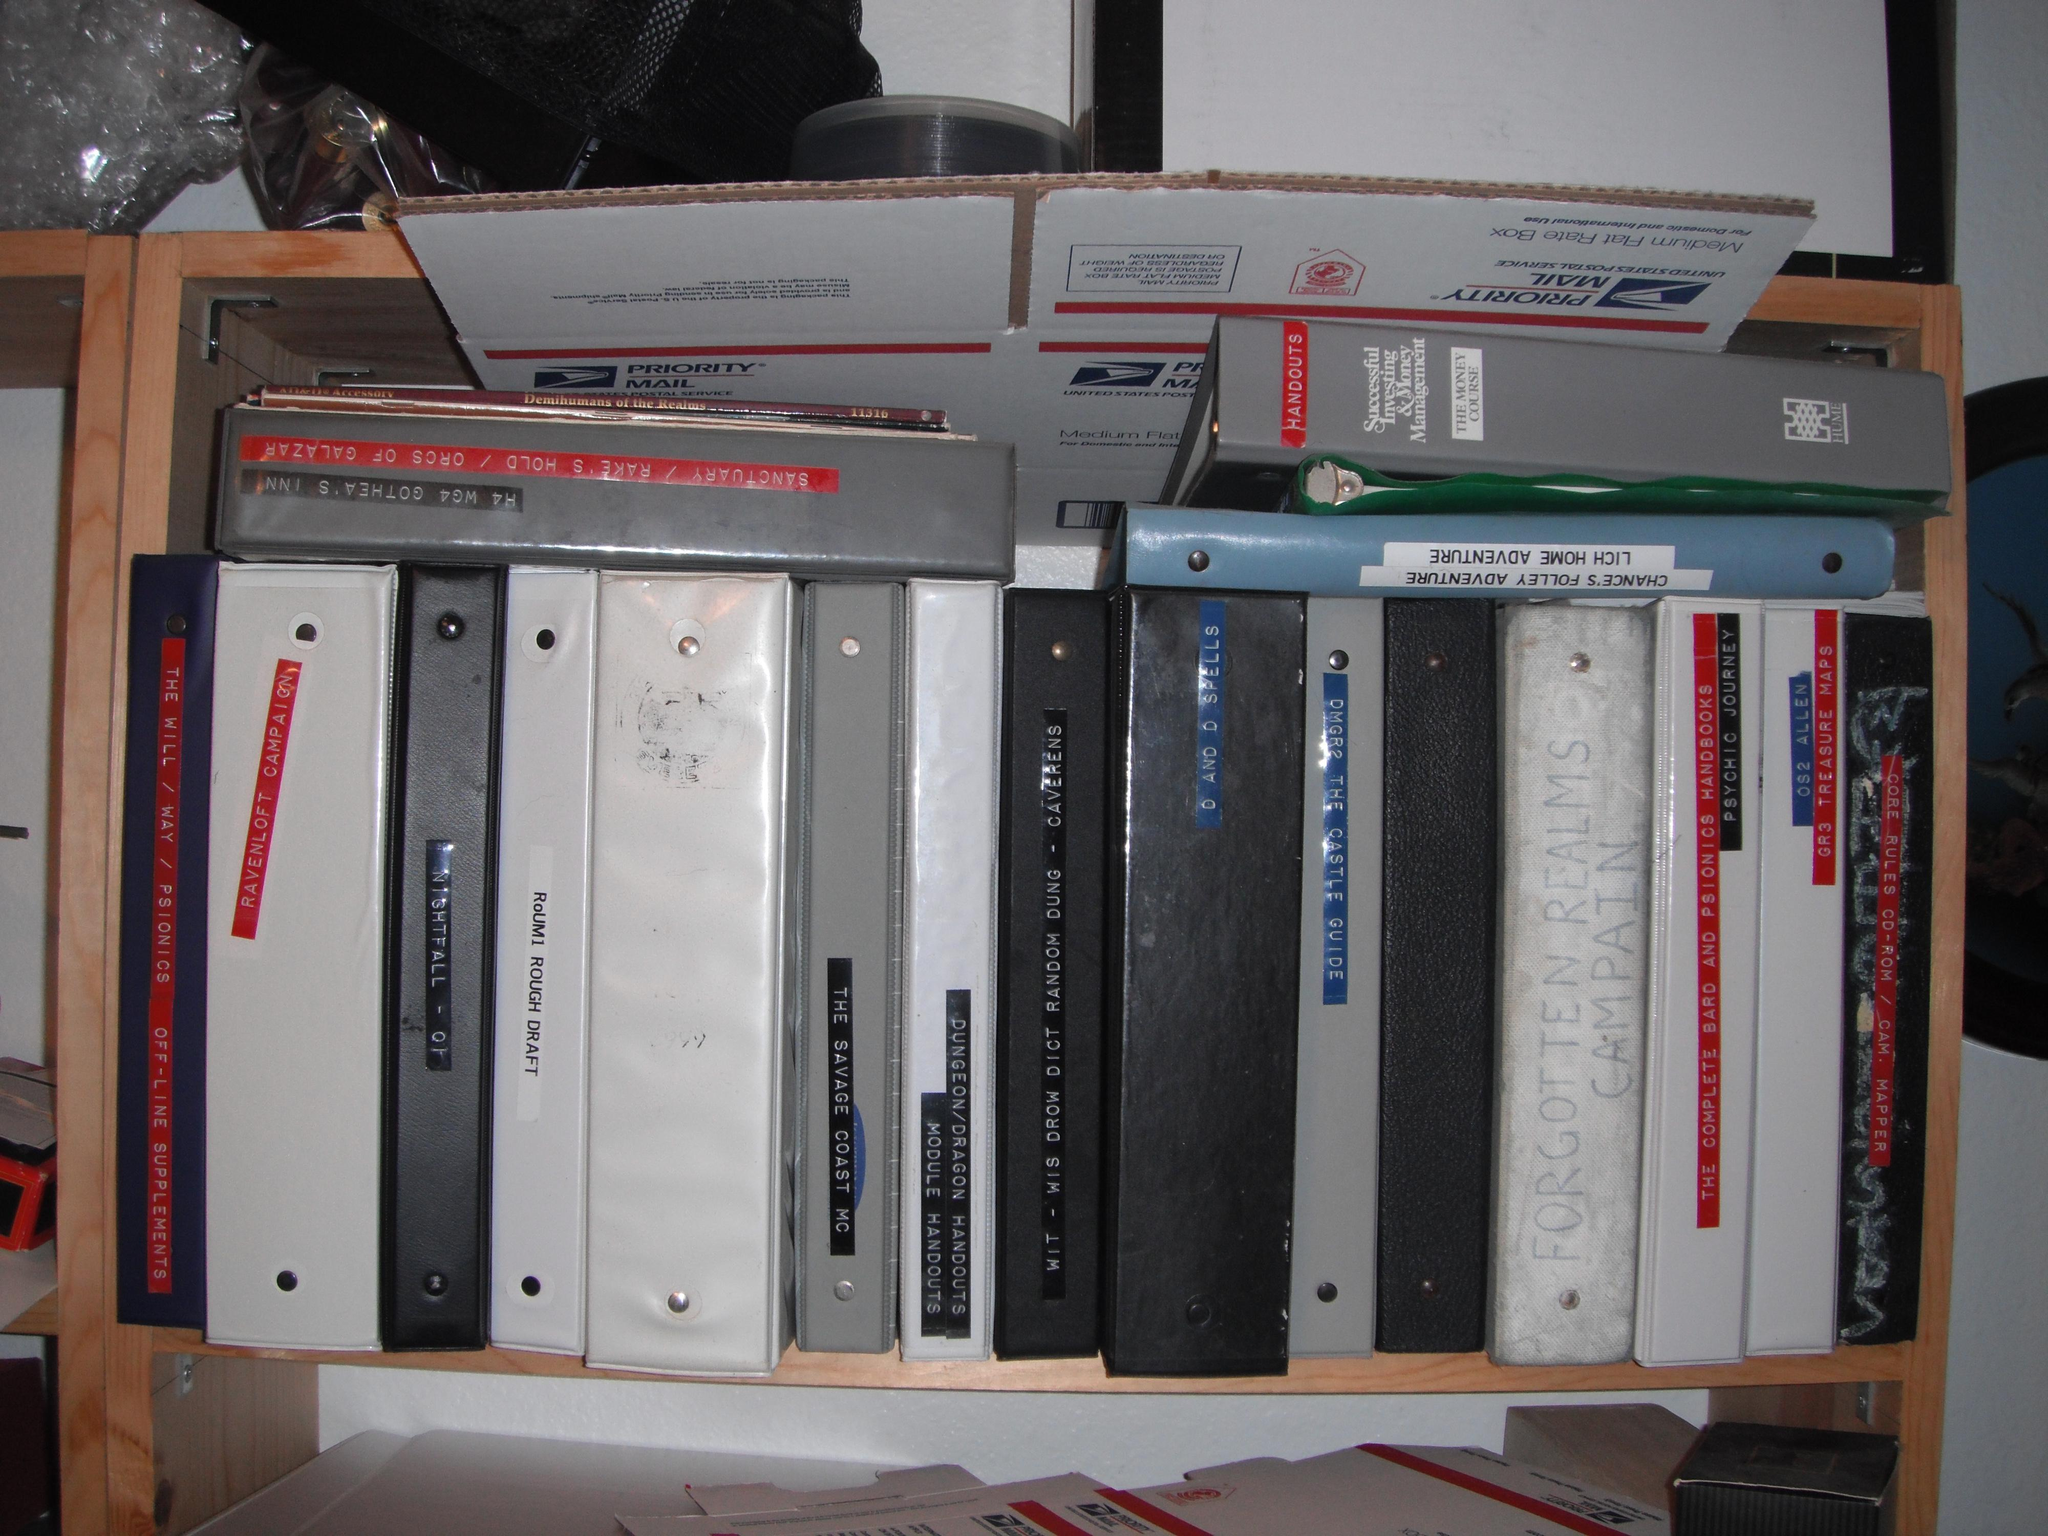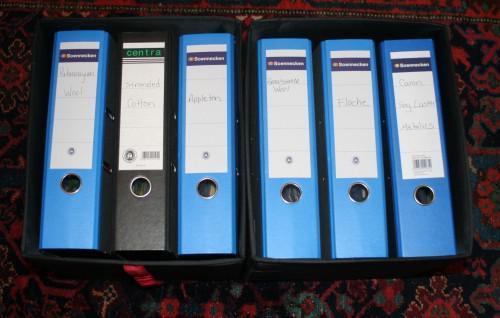The first image is the image on the left, the second image is the image on the right. Examine the images to the left and right. Is the description "1 of the images has 6 shelf objects lined up in a row next to each other." accurate? Answer yes or no. Yes. The first image is the image on the left, the second image is the image on the right. Given the left and right images, does the statement "Exactly six binders of equal size are shown in one image." hold true? Answer yes or no. Yes. 